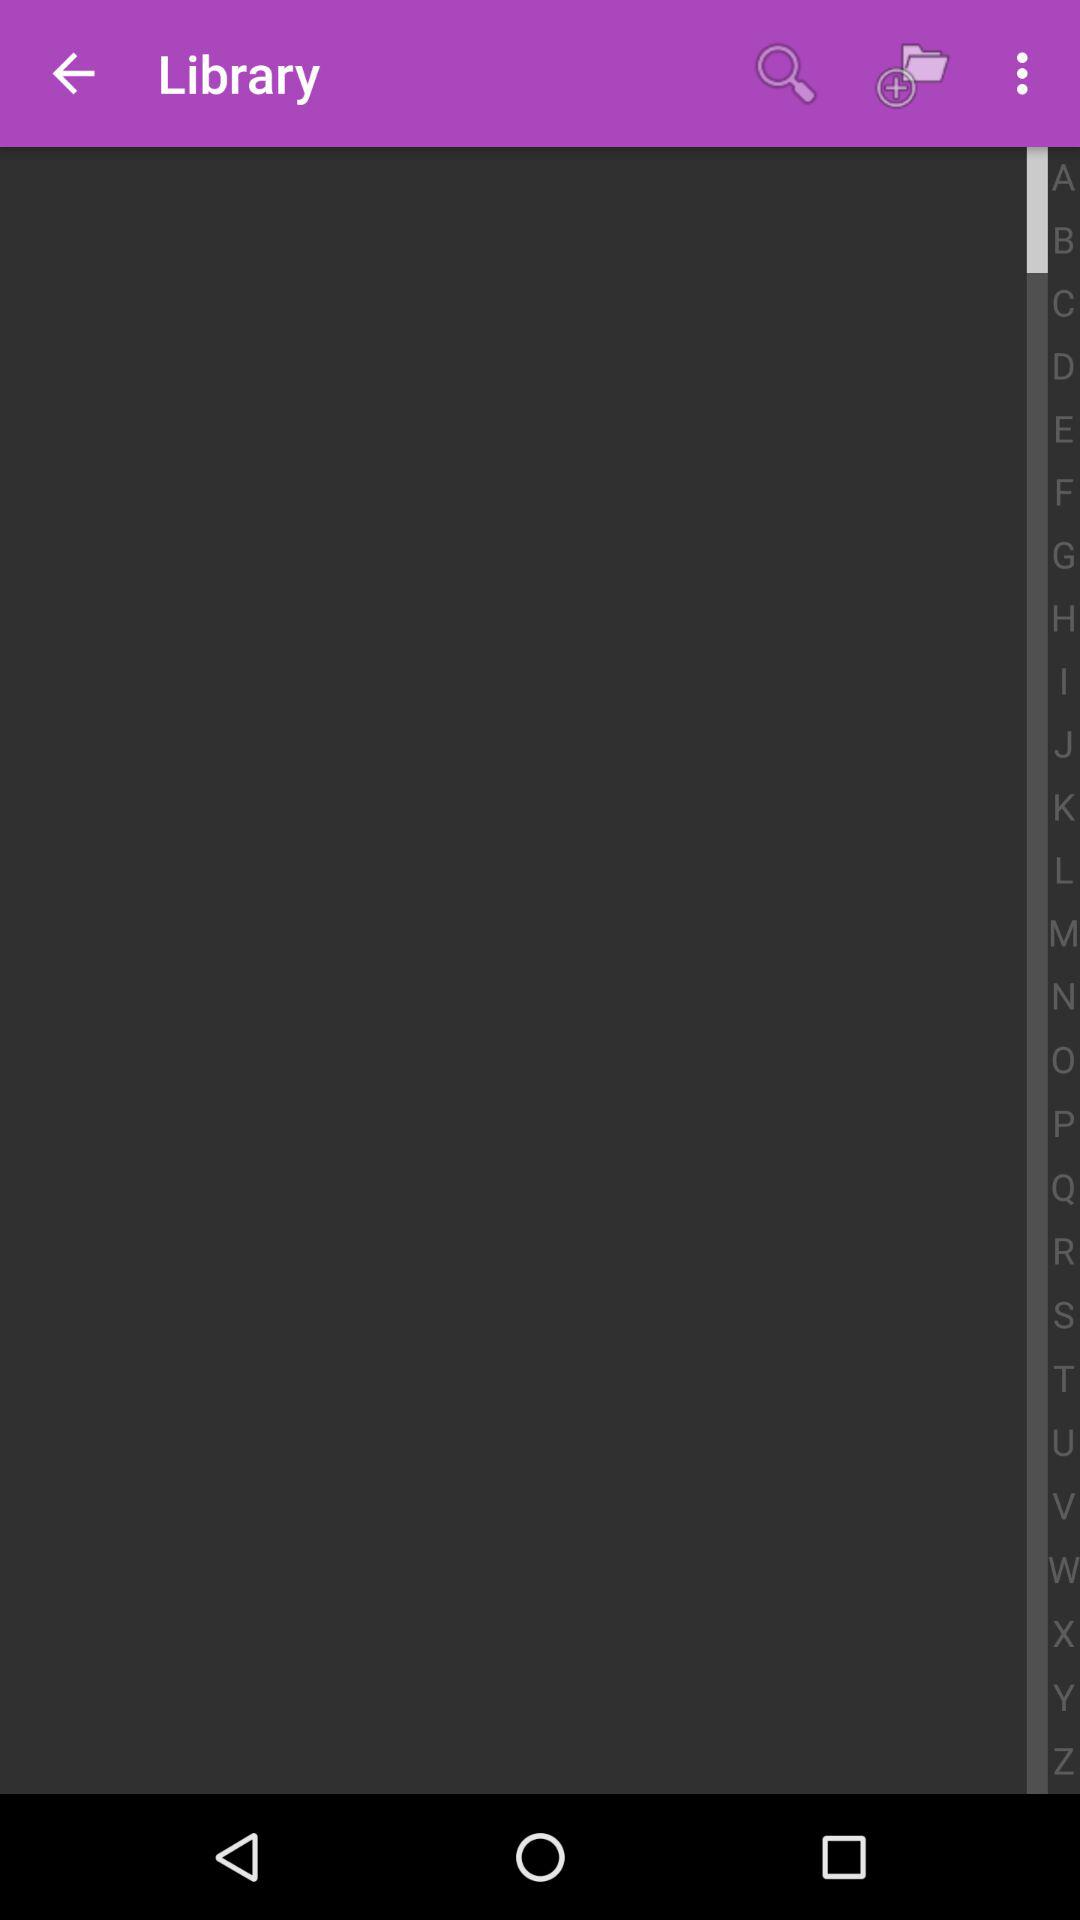How many alphabets are there in the alphabet bar?
Answer the question using a single word or phrase. 26 